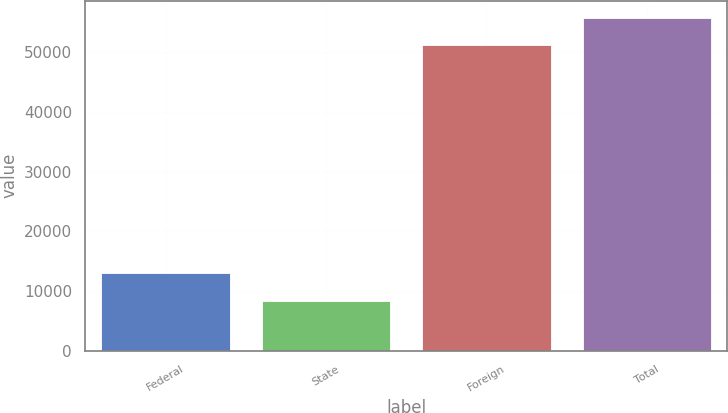Convert chart. <chart><loc_0><loc_0><loc_500><loc_500><bar_chart><fcel>Federal<fcel>State<fcel>Foreign<fcel>Total<nl><fcel>12970.8<fcel>8369<fcel>51189<fcel>55790.8<nl></chart> 